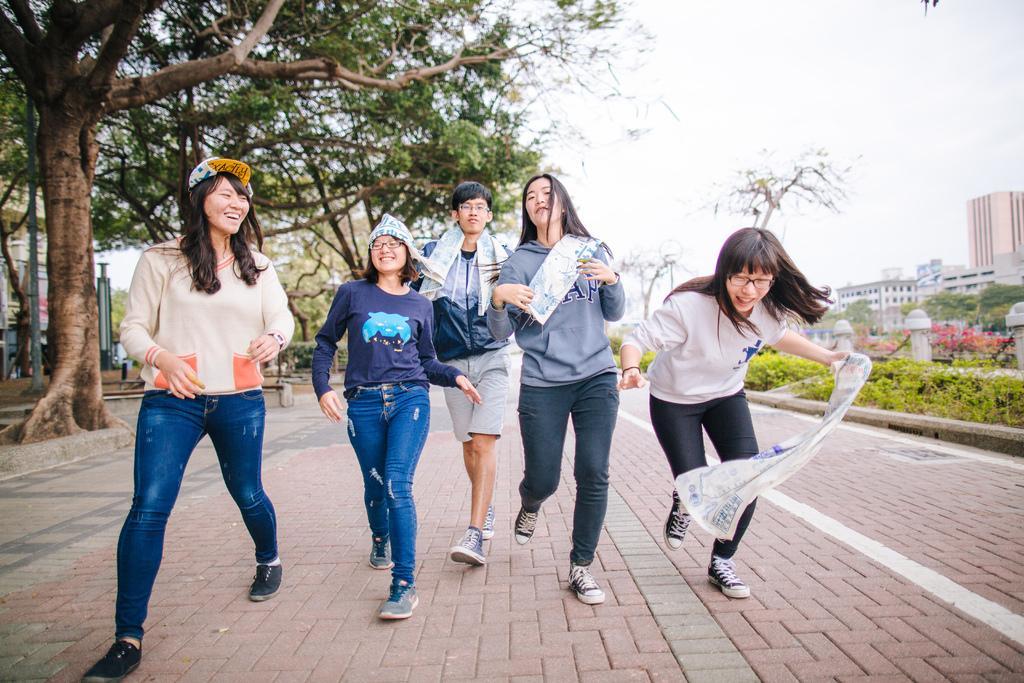How would you summarize this image in a sentence or two? In this picture we can observe five members walking in this path. Four of them are women and one of them is a man. All of them are smiling. We can observe some trees and plants in this picture. In the background there are buildings and a sky. 